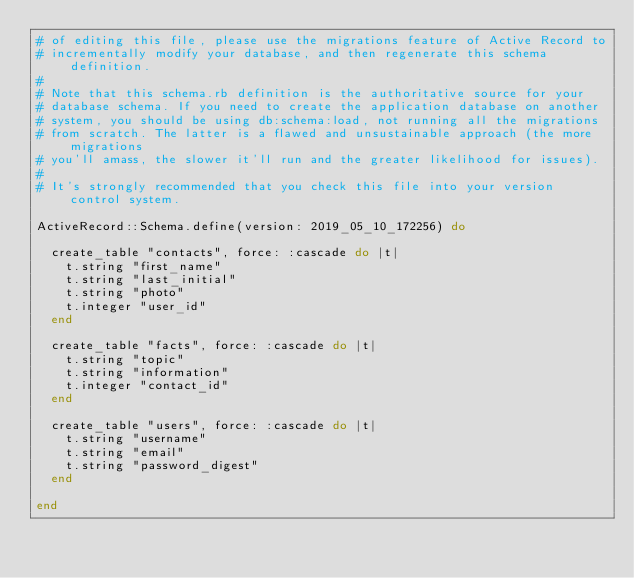Convert code to text. <code><loc_0><loc_0><loc_500><loc_500><_Ruby_># of editing this file, please use the migrations feature of Active Record to
# incrementally modify your database, and then regenerate this schema definition.
#
# Note that this schema.rb definition is the authoritative source for your
# database schema. If you need to create the application database on another
# system, you should be using db:schema:load, not running all the migrations
# from scratch. The latter is a flawed and unsustainable approach (the more migrations
# you'll amass, the slower it'll run and the greater likelihood for issues).
#
# It's strongly recommended that you check this file into your version control system.

ActiveRecord::Schema.define(version: 2019_05_10_172256) do

  create_table "contacts", force: :cascade do |t|
    t.string "first_name"
    t.string "last_initial"
    t.string "photo"
    t.integer "user_id"
  end

  create_table "facts", force: :cascade do |t|
    t.string "topic"
    t.string "information"
    t.integer "contact_id"
  end

  create_table "users", force: :cascade do |t|
    t.string "username"
    t.string "email"
    t.string "password_digest"
  end

end
</code> 